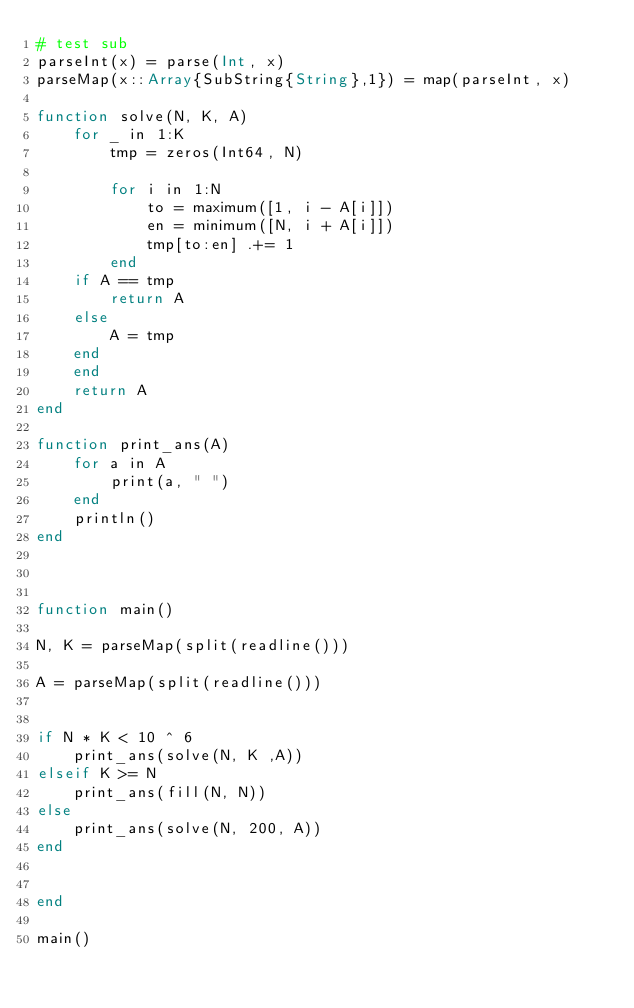<code> <loc_0><loc_0><loc_500><loc_500><_Julia_># test sub
parseInt(x) = parse(Int, x)
parseMap(x::Array{SubString{String},1}) = map(parseInt, x)

function solve(N, K, A)
    for _ in 1:K
        tmp = zeros(Int64, N)

        for i in 1:N
            to = maximum([1, i - A[i]])
            en = minimum([N, i + A[i]])
            tmp[to:en] .+= 1
        end
    if A == tmp
        return A
    else
        A = tmp
    end
    end
    return A
end

function print_ans(A)
    for a in A
        print(a, " ")
    end
    println()
end



function main()

N, K = parseMap(split(readline()))

A = parseMap(split(readline()))


if N * K < 10 ^ 6
    print_ans(solve(N, K ,A))
elseif K >= N
    print_ans(fill(N, N))
else
    print_ans(solve(N, 200, A))
end


end

main()
</code> 